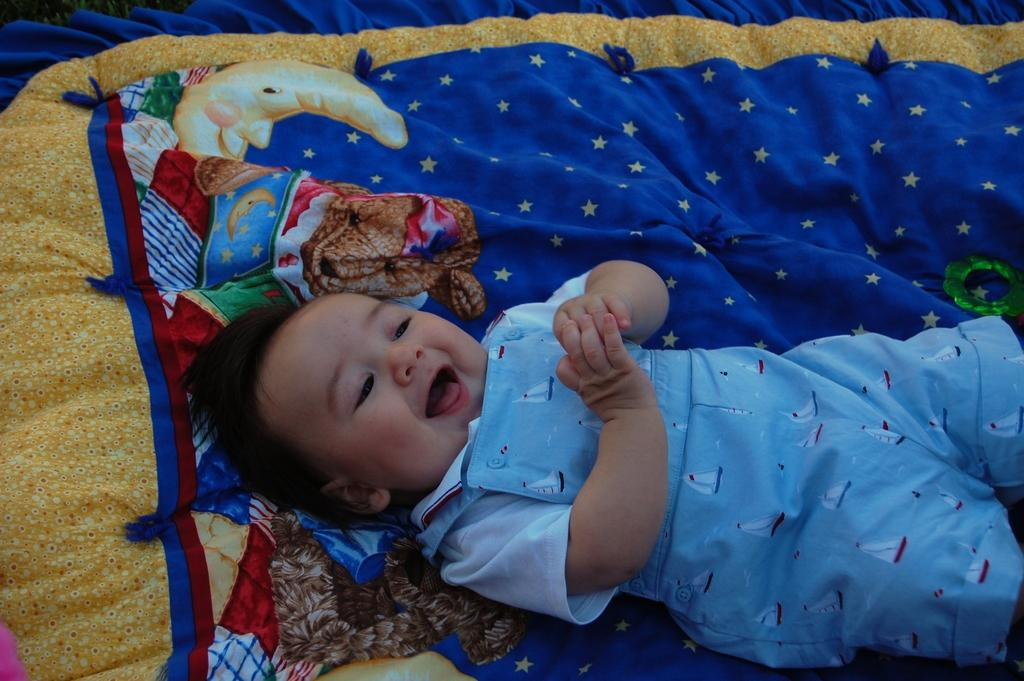What is the main subject of the image? There is a baby in the image. What is the baby's expression in the image? The baby is smiling in the image. What color is the cloth at the bottom of the image? There is a blue color cloth at the bottom of the image. What type of club does the baby belong to in the image? There is no club mentioned or depicted in the image; it simply features a baby smiling. 